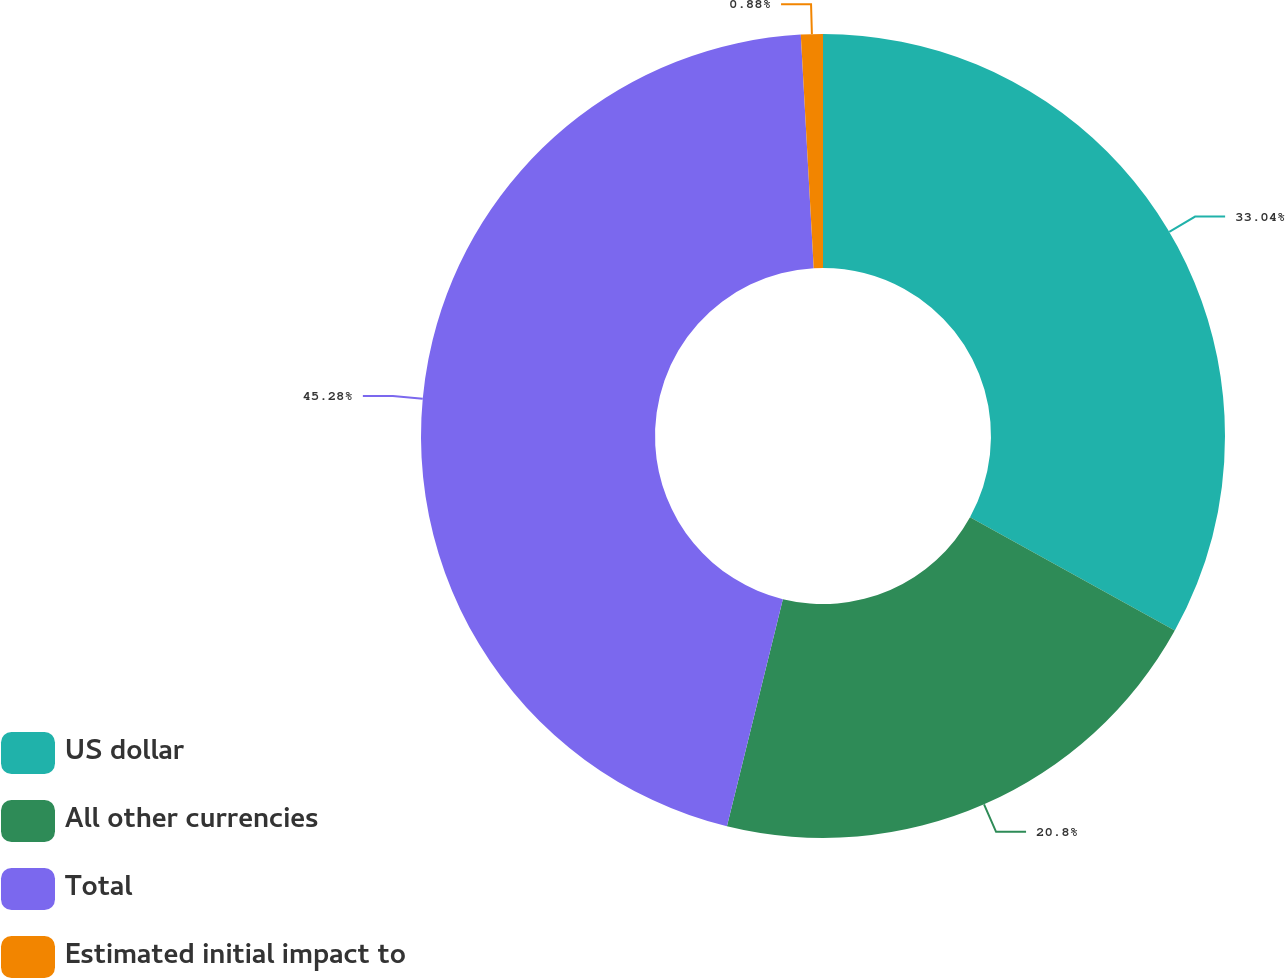Convert chart to OTSL. <chart><loc_0><loc_0><loc_500><loc_500><pie_chart><fcel>US dollar<fcel>All other currencies<fcel>Total<fcel>Estimated initial impact to<nl><fcel>33.04%<fcel>20.8%<fcel>45.28%<fcel>0.88%<nl></chart> 